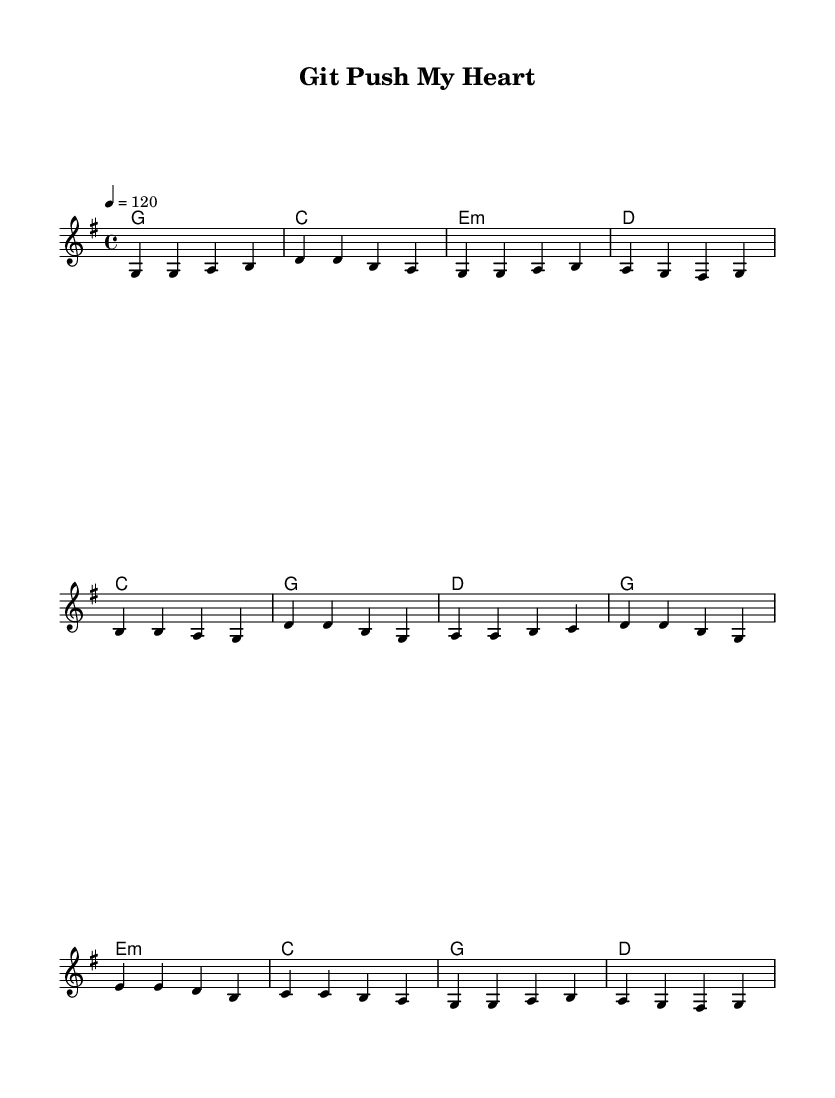What is the key signature of this music? The key signature is G major, which has one sharp (F#).
Answer: G major What is the time signature of this music? The time signature is 4/4, indicating four beats per measure.
Answer: 4/4 What is the tempo indication? The tempo indicates 120 beats per minute, which is a moderate tempo for this piece.
Answer: 120 How many measures are in the verse section? The verse consists of four measures, as indicated in the melody section provided.
Answer: Four measures What is the title of this song? The title is "Git Push My Heart," which is indicated in the header section of the music.
Answer: Git Push My Heart What is the function of the lyrics in the chorus with respect to the song's theme? The lyrics in the chorus reflect a romantic relationship using coding metaphors, highlighting the merging of branches and the concept of open source as a metaphor for love.
Answer: Romantic coding metaphors How does the bridge differ musically from the verse and chorus? The bridge introduces a different chord progression and melody to create contrast and lend emotional depth to the piece, using minor harmonies compared to the major harmonies in the verse and chorus.
Answer: Different chord progression and melody 